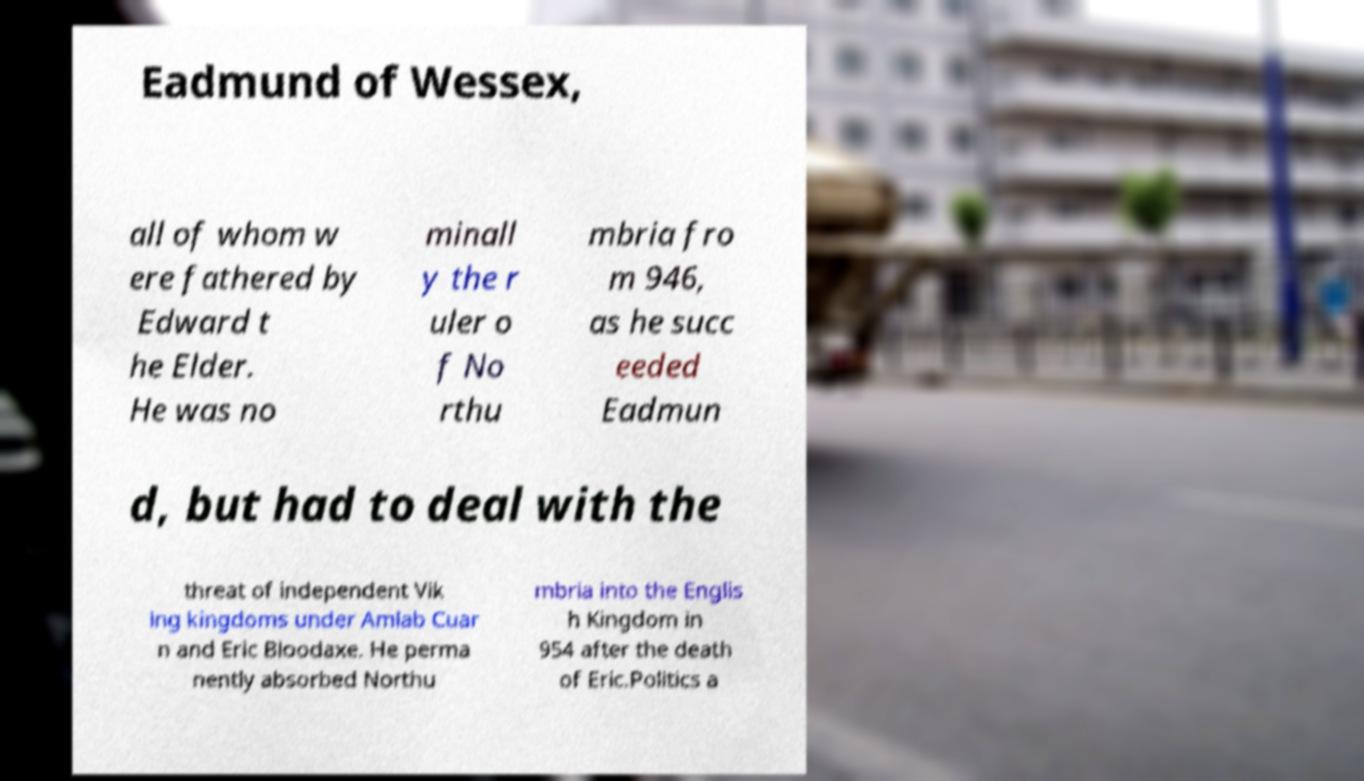Can you read and provide the text displayed in the image?This photo seems to have some interesting text. Can you extract and type it out for me? Eadmund of Wessex, all of whom w ere fathered by Edward t he Elder. He was no minall y the r uler o f No rthu mbria fro m 946, as he succ eeded Eadmun d, but had to deal with the threat of independent Vik ing kingdoms under Amlab Cuar n and Eric Bloodaxe. He perma nently absorbed Northu mbria into the Englis h Kingdom in 954 after the death of Eric.Politics a 